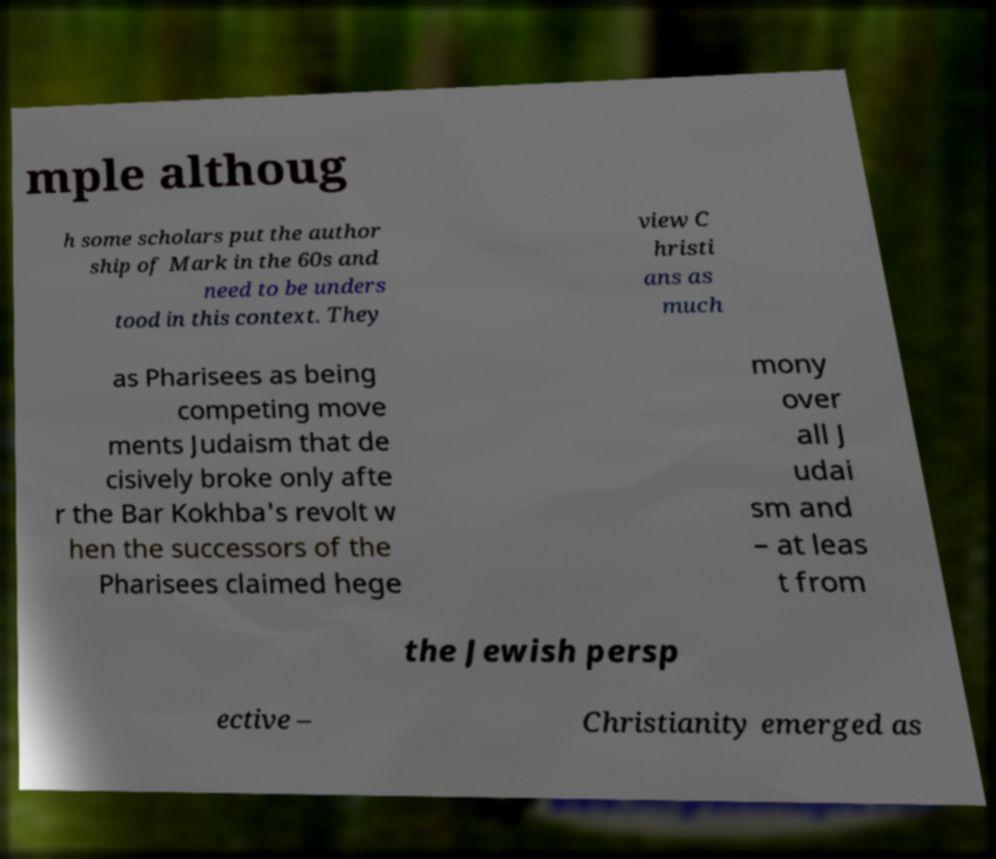Can you accurately transcribe the text from the provided image for me? mple althoug h some scholars put the author ship of Mark in the 60s and need to be unders tood in this context. They view C hristi ans as much as Pharisees as being competing move ments Judaism that de cisively broke only afte r the Bar Kokhba's revolt w hen the successors of the Pharisees claimed hege mony over all J udai sm and – at leas t from the Jewish persp ective – Christianity emerged as 